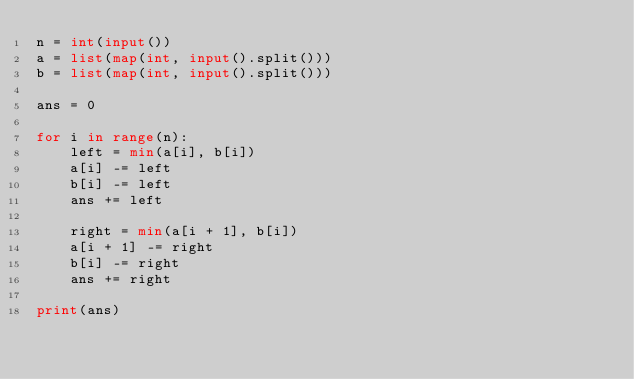<code> <loc_0><loc_0><loc_500><loc_500><_Python_>n = int(input())
a = list(map(int, input().split()))
b = list(map(int, input().split()))

ans = 0

for i in range(n):
    left = min(a[i], b[i])
    a[i] -= left
    b[i] -= left
    ans += left

    right = min(a[i + 1], b[i])
    a[i + 1] -= right
    b[i] -= right
    ans += right

print(ans)
</code> 